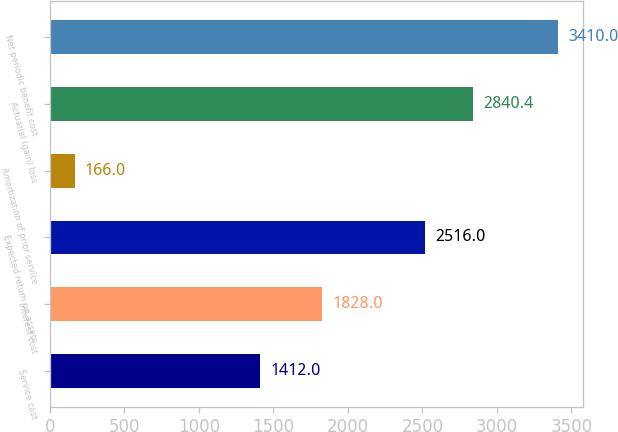Convert chart to OTSL. <chart><loc_0><loc_0><loc_500><loc_500><bar_chart><fcel>Service cost<fcel>Interest cost<fcel>Expected return on assets<fcel>Amortization of prior service<fcel>Actuarial (gain) loss<fcel>Net periodic benefit cost<nl><fcel>1412<fcel>1828<fcel>2516<fcel>166<fcel>2840.4<fcel>3410<nl></chart> 